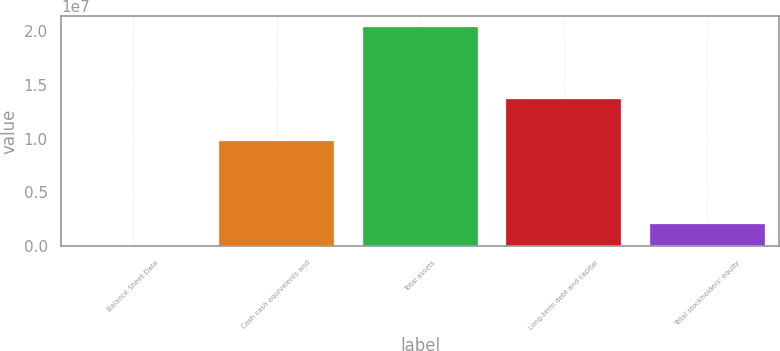Convert chart. <chart><loc_0><loc_0><loc_500><loc_500><bar_chart><fcel>Balance Sheet Data<fcel>Cash cash equivalents and<fcel>Total assets<fcel>Long-term debt and capital<fcel>Total stockholders' equity<nl><fcel>2013<fcel>9.7394e+06<fcel>2.03564e+07<fcel>1.36317e+07<fcel>2.03745e+06<nl></chart> 